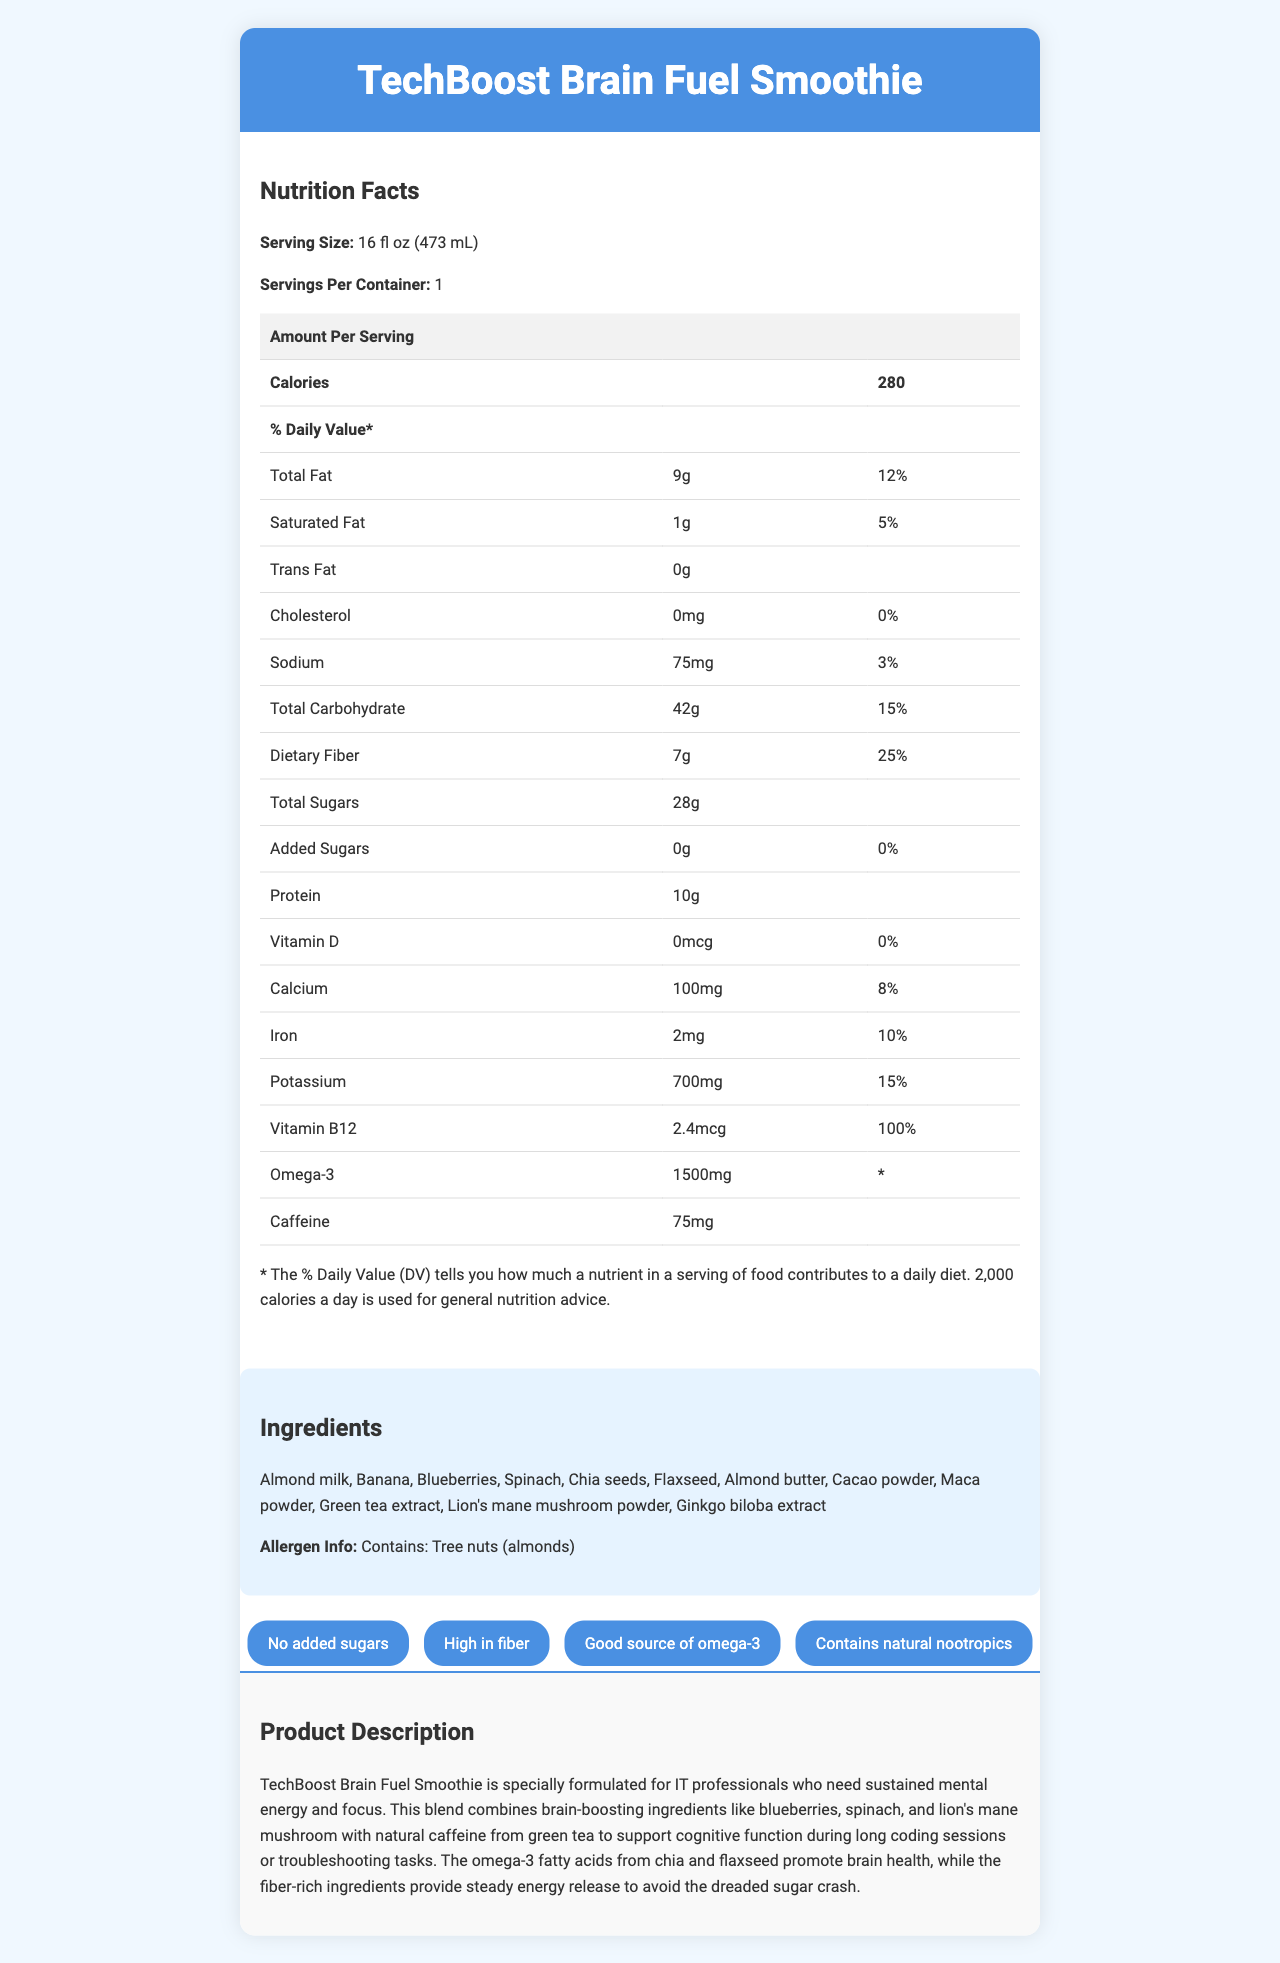what is the product name? The product name is prominently displayed at the top of the document within the header section.
Answer: TechBoost Brain Fuel Smoothie how many servings are in each container? The document states that there is 1 serving per container.
Answer: 1 what is the total fat content per serving? According to the nutrition facts table, the total fat content per serving is 9 grams.
Answer: 9g what is the amount of dietary fiber per serving? The nutrition facts table lists dietary fiber as 7 grams per serving.
Answer: 7g are there any tree nuts in the ingredients? The allergen information section states that the product contains tree nuts (almonds).
Answer: Yes what is the daily value percentage for vitamin B12? The nutrition facts table shows that vitamin B12 contributes 100% of the daily value.
Answer: 100% what is the caloric content per serving? The nutrition facts table indicates that there are 280 calories per serving.
Answer: 280 which ingredient provides natural caffeine? A. Almond milk B. Green tea extract C. Spinach D. Cacao powder The document lists green tea extract as an ingredient, which is a natural source of caffeine.
Answer: B which nutrient does this smoothie provide 25% of the daily value for? A. Protein B. Calcium C. Dietary Fiber D. Potassium According to the nutrition facts table, dietary fiber makes up 25% of the daily value per serving.
Answer: C is there any added sugar in this smoothie? The nutrition facts table states that there are 0 grams of added sugars, and one of the product claims is "No added sugars."
Answer: No does the smoothie contain ingredients that are high in fiber? The document claims that the product is high in fiber and lists fiber-rich ingredients like chia seeds and flaxseed.
Answer: Yes summarize the main purpose of this product The summary should capture the essence of the document, highlighting that the smoothie is formulated specifically for IT professionals to maintain mental energy and focus during long coding sessions, supported by nutritional components like omega-3 and fiber.
Answer: The TechBoost Brain Fuel Smoothie is designed to provide IT professionals with sustained mental energy and focus. It combines brain-boosting ingredients and natural sources of caffeine to support cognitive function, while also being rich in fiber and omega-3 fatty acids. what flavor is this smoothie? The document does not provide any information regarding the flavor of the smoothie.
Answer: Cannot be determined 